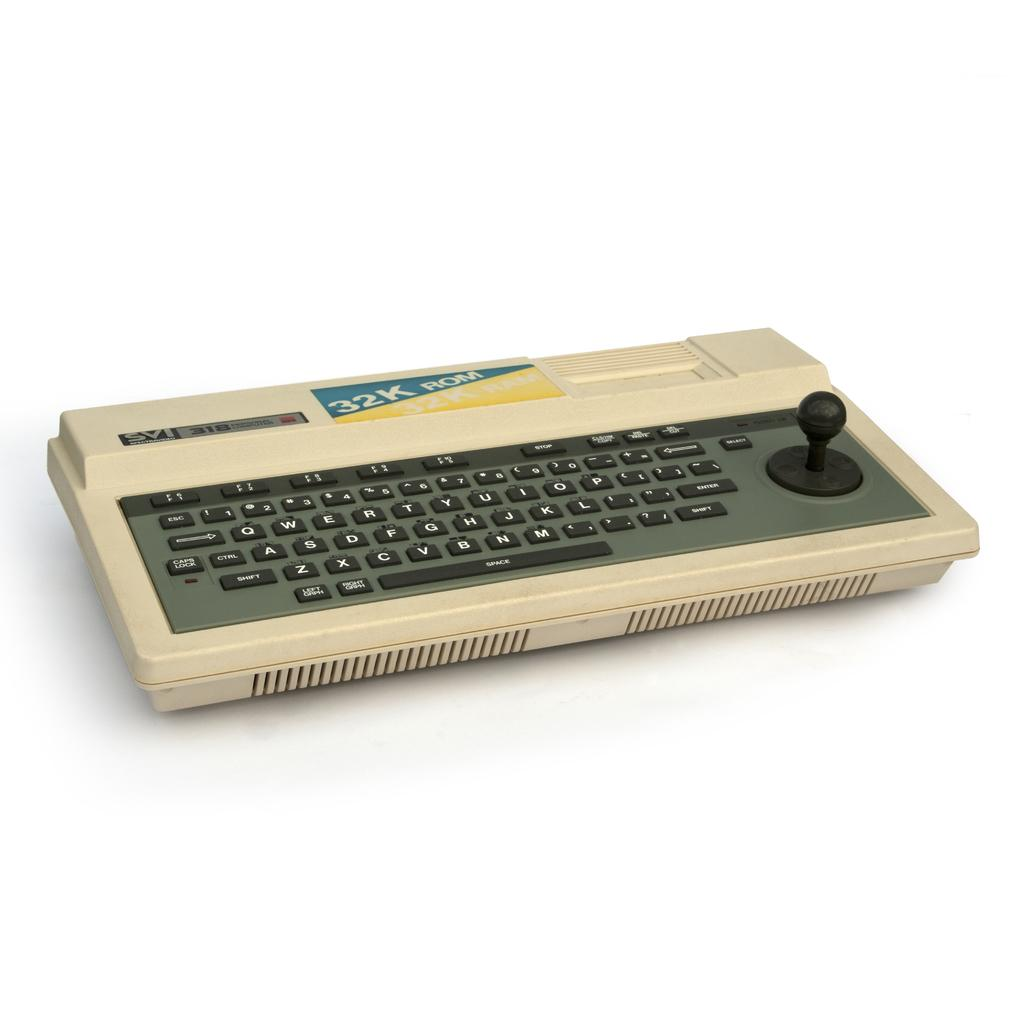<image>
Give a short and clear explanation of the subsequent image. a keyboard with a 32k ROM sticker on it. 